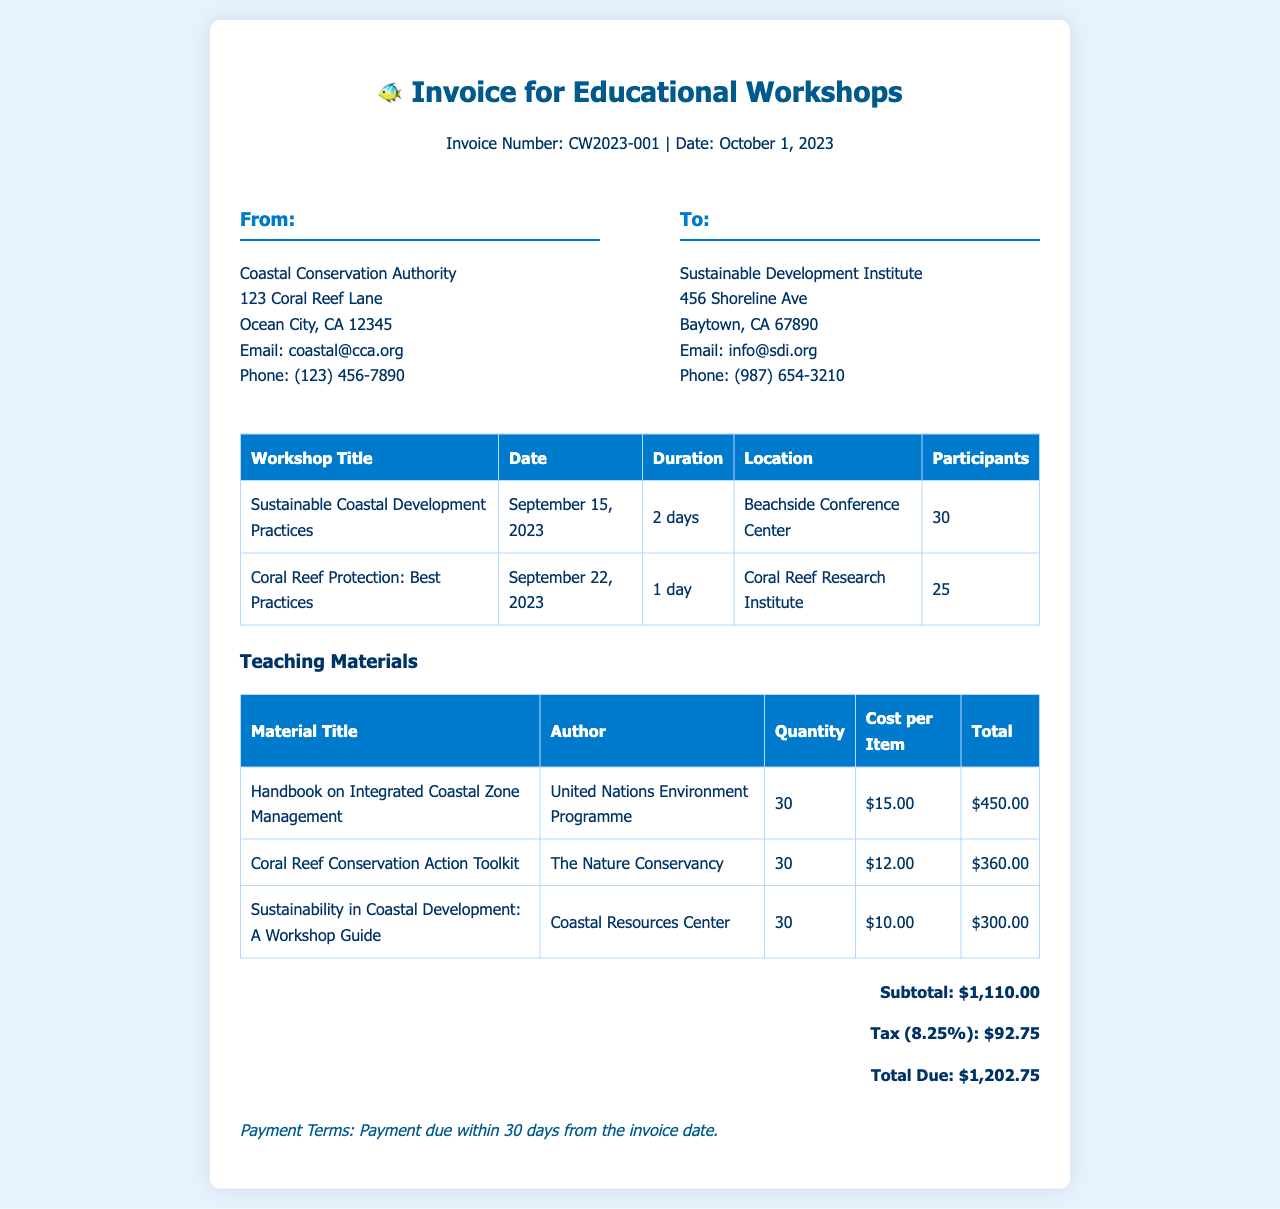What is the invoice number? The invoice number is listed at the top of the document next to the title.
Answer: CW2023-001 What is the total due amount? The total due amount is calculated at the bottom of the invoice, considering subtotals and tax.
Answer: $1,202.75 How many participants attended the 'Coral Reef Protection: Best Practices' workshop? The number of participants is specified in the table for each workshop.
Answer: 25 What is the date of the 'Sustainable Coastal Development Practices' workshop? The date is listed in the workshop details table.
Answer: September 15, 2023 How many teaching materials were provided in total? The quantity of each material is summed from the teaching materials table.
Answer: 90 What is the tax percentage applied to the invoice total? The tax percentage is noted in the totals section of the document.
Answer: 8.25% Who is the author of the 'Handbook on Integrated Coastal Zone Management'? The author is mentioned in the teaching materials table for that specific title.
Answer: United Nations Environment Programme What is the duration of the 'Coral Reef Protection: Best Practices' workshop? The duration is detailed in the workshop information section of the document.
Answer: 1 day 